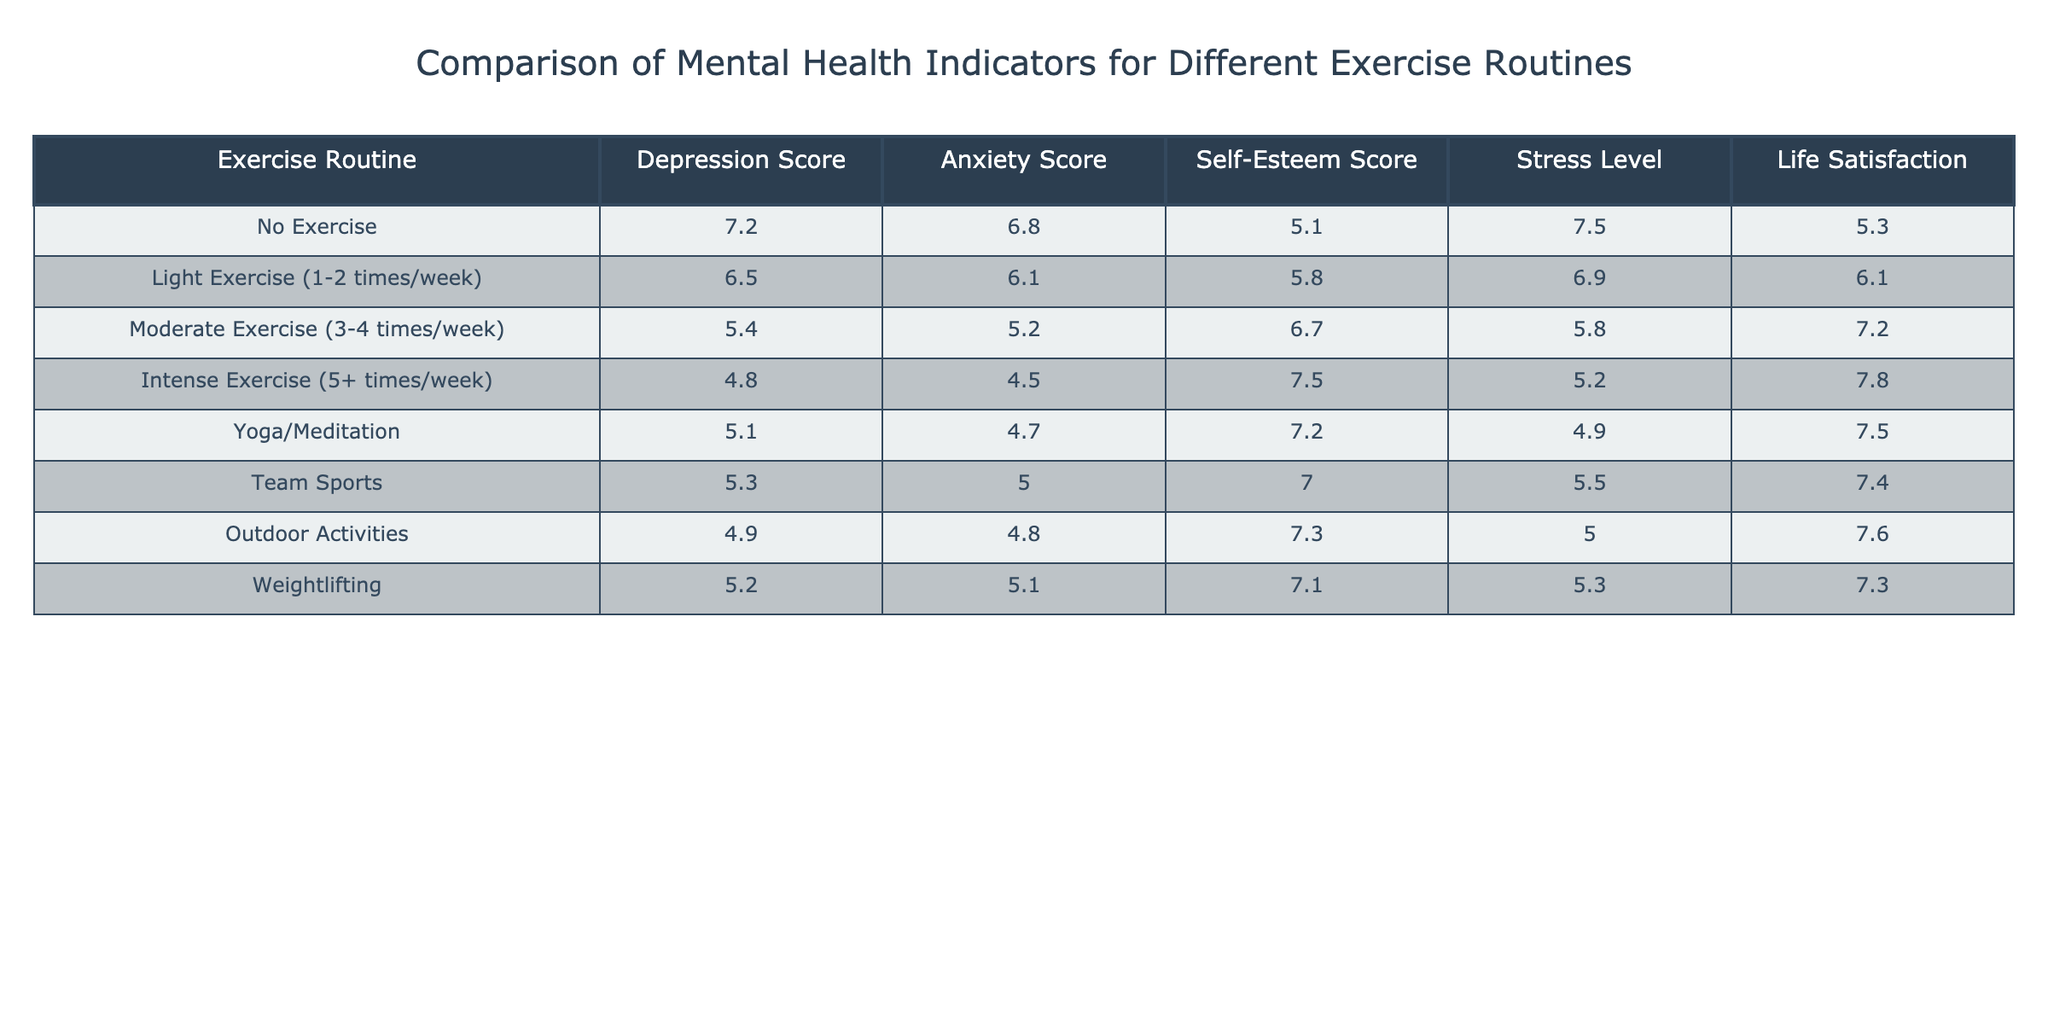What is the Depression Score for individuals with intense exercise routines? According to the table, the Depression Score for individuals with intense exercise routines is listed directly as 4.8.
Answer: 4.8 What is the average Anxiety Score for all exercise routines? To find the average Anxiety Score, add all the scores: 6.8 + 6.1 + 5.2 + 4.5 + 4.7 + 5.0 + 4.8 + 5.1 = 43.2. Then divide by the number of routines (8): 43.2 / 8 = 5.4.
Answer: 5.4 Is the Life Satisfaction score for Yoga/Meditation higher than that for Outdoor Activities? The Life Satisfaction score for Yoga/Meditation is 7.5, and for Outdoor Activities, it is 7.6. Since 7.5 is less than 7.6, the statement is false.
Answer: No Which exercise routine has the highest Self-Esteem Score and what is that score? The routine with the highest Self-Esteem Score is Intense Exercise, which has a score of 7.5.
Answer: 7.5 What is the difference in Stress Level between No Exercise and Moderate Exercise? The Stress Level for No Exercise is 7.5 and for Moderate Exercise it is 5.8. To find the difference, subtract: 7.5 - 5.8 = 1.7.
Answer: 1.7 How does the Depression Score of individuals who do Weightlifting compare with those doing Yoga/Meditation? The Depression Score for Weightlifting is 5.2 and for Yoga/Meditation it is 5.1. Weightlifting has a higher score than Yoga/Meditation by 0.1.
Answer: Weightlifting is higher by 0.1 What exercise routine corresponds to the lowest score in Stress Level and what is that score? Looking at the Stress Level column, the lowest score is 4.9, which corresponds to Yoga/Meditation.
Answer: 4.9 Are the Anxiety and Depression Scores related for individuals who engage in Team Sports? For Team Sports, the Anxiety Score is 5.0 and the Depression Score is 5.3. While both scores are low, they cannot be definitively stated as related without deeper analysis.
Answer: No Which exercise routine shows the most improvement in Life Satisfaction from No Exercise? The Life Satisfaction for No Exercise is 5.3, and for Intense Exercise, it is 7.8. The improvement can be computed as 7.8 - 5.3 = 2.5. Intense Exercise shows the most improvement.
Answer: Intense Exercise with 2.5 What are the combined scores of Self-Esteem for Light Exercise and Moderate Exercise? The Self-Esteem Score for Light Exercise is 5.8 and for Moderate Exercise is 6.7. Combining these gives 5.8 + 6.7 = 12.5.
Answer: 12.5 